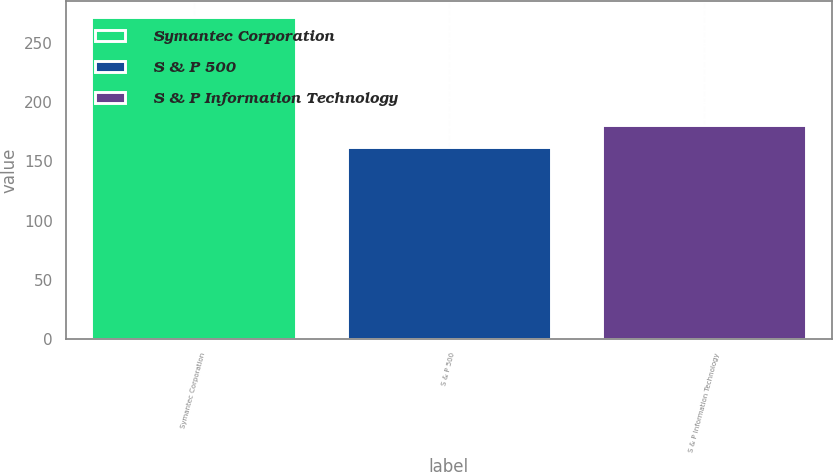Convert chart to OTSL. <chart><loc_0><loc_0><loc_500><loc_500><bar_chart><fcel>Symantec Corporation<fcel>S & P 500<fcel>S & P Information Technology<nl><fcel>271.74<fcel>161.88<fcel>180.94<nl></chart> 